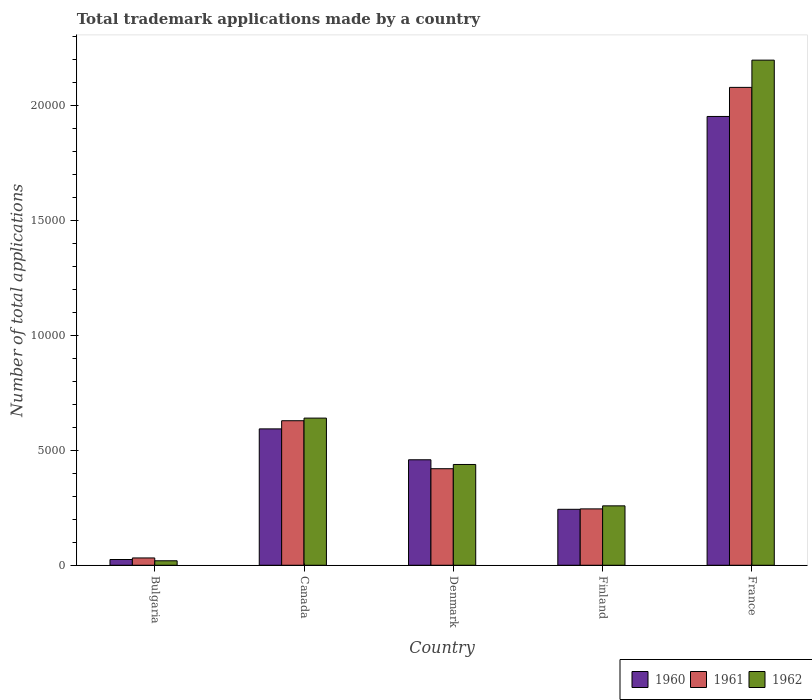How many groups of bars are there?
Make the answer very short. 5. Are the number of bars per tick equal to the number of legend labels?
Ensure brevity in your answer.  Yes. What is the label of the 4th group of bars from the left?
Ensure brevity in your answer.  Finland. In how many cases, is the number of bars for a given country not equal to the number of legend labels?
Provide a short and direct response. 0. What is the number of applications made by in 1962 in Bulgaria?
Offer a terse response. 195. Across all countries, what is the maximum number of applications made by in 1960?
Ensure brevity in your answer.  1.95e+04. Across all countries, what is the minimum number of applications made by in 1960?
Your answer should be very brief. 250. What is the total number of applications made by in 1960 in the graph?
Your answer should be compact. 3.27e+04. What is the difference between the number of applications made by in 1961 in Finland and that in France?
Give a very brief answer. -1.83e+04. What is the difference between the number of applications made by in 1960 in France and the number of applications made by in 1962 in Denmark?
Offer a terse response. 1.51e+04. What is the average number of applications made by in 1961 per country?
Make the answer very short. 6802.6. What is the difference between the number of applications made by of/in 1960 and number of applications made by of/in 1962 in Finland?
Your response must be concise. -150. What is the ratio of the number of applications made by in 1961 in Canada to that in Finland?
Make the answer very short. 2.56. What is the difference between the highest and the second highest number of applications made by in 1961?
Keep it short and to the point. 1.45e+04. What is the difference between the highest and the lowest number of applications made by in 1962?
Keep it short and to the point. 2.18e+04. Is the sum of the number of applications made by in 1960 in Bulgaria and Finland greater than the maximum number of applications made by in 1962 across all countries?
Offer a terse response. No. Are all the bars in the graph horizontal?
Offer a very short reply. No. Are the values on the major ticks of Y-axis written in scientific E-notation?
Keep it short and to the point. No. Does the graph contain any zero values?
Provide a succinct answer. No. Does the graph contain grids?
Provide a succinct answer. No. Where does the legend appear in the graph?
Make the answer very short. Bottom right. How many legend labels are there?
Make the answer very short. 3. What is the title of the graph?
Ensure brevity in your answer.  Total trademark applications made by a country. Does "1982" appear as one of the legend labels in the graph?
Offer a very short reply. No. What is the label or title of the Y-axis?
Your answer should be compact. Number of total applications. What is the Number of total applications of 1960 in Bulgaria?
Provide a succinct answer. 250. What is the Number of total applications of 1961 in Bulgaria?
Make the answer very short. 318. What is the Number of total applications of 1962 in Bulgaria?
Offer a terse response. 195. What is the Number of total applications of 1960 in Canada?
Provide a short and direct response. 5927. What is the Number of total applications of 1961 in Canada?
Your response must be concise. 6281. What is the Number of total applications of 1962 in Canada?
Keep it short and to the point. 6395. What is the Number of total applications in 1960 in Denmark?
Your response must be concise. 4584. What is the Number of total applications in 1961 in Denmark?
Keep it short and to the point. 4196. What is the Number of total applications in 1962 in Denmark?
Make the answer very short. 4380. What is the Number of total applications of 1960 in Finland?
Keep it short and to the point. 2432. What is the Number of total applications of 1961 in Finland?
Provide a succinct answer. 2450. What is the Number of total applications of 1962 in Finland?
Ensure brevity in your answer.  2582. What is the Number of total applications of 1960 in France?
Your answer should be compact. 1.95e+04. What is the Number of total applications in 1961 in France?
Provide a succinct answer. 2.08e+04. What is the Number of total applications of 1962 in France?
Make the answer very short. 2.20e+04. Across all countries, what is the maximum Number of total applications in 1960?
Your answer should be compact. 1.95e+04. Across all countries, what is the maximum Number of total applications of 1961?
Give a very brief answer. 2.08e+04. Across all countries, what is the maximum Number of total applications in 1962?
Keep it short and to the point. 2.20e+04. Across all countries, what is the minimum Number of total applications in 1960?
Make the answer very short. 250. Across all countries, what is the minimum Number of total applications in 1961?
Offer a terse response. 318. Across all countries, what is the minimum Number of total applications in 1962?
Offer a very short reply. 195. What is the total Number of total applications of 1960 in the graph?
Give a very brief answer. 3.27e+04. What is the total Number of total applications of 1961 in the graph?
Give a very brief answer. 3.40e+04. What is the total Number of total applications of 1962 in the graph?
Ensure brevity in your answer.  3.55e+04. What is the difference between the Number of total applications in 1960 in Bulgaria and that in Canada?
Ensure brevity in your answer.  -5677. What is the difference between the Number of total applications in 1961 in Bulgaria and that in Canada?
Make the answer very short. -5963. What is the difference between the Number of total applications in 1962 in Bulgaria and that in Canada?
Offer a very short reply. -6200. What is the difference between the Number of total applications in 1960 in Bulgaria and that in Denmark?
Offer a very short reply. -4334. What is the difference between the Number of total applications of 1961 in Bulgaria and that in Denmark?
Ensure brevity in your answer.  -3878. What is the difference between the Number of total applications of 1962 in Bulgaria and that in Denmark?
Offer a very short reply. -4185. What is the difference between the Number of total applications of 1960 in Bulgaria and that in Finland?
Provide a succinct answer. -2182. What is the difference between the Number of total applications in 1961 in Bulgaria and that in Finland?
Your answer should be compact. -2132. What is the difference between the Number of total applications in 1962 in Bulgaria and that in Finland?
Your response must be concise. -2387. What is the difference between the Number of total applications of 1960 in Bulgaria and that in France?
Provide a short and direct response. -1.93e+04. What is the difference between the Number of total applications of 1961 in Bulgaria and that in France?
Provide a succinct answer. -2.04e+04. What is the difference between the Number of total applications in 1962 in Bulgaria and that in France?
Ensure brevity in your answer.  -2.18e+04. What is the difference between the Number of total applications in 1960 in Canada and that in Denmark?
Offer a terse response. 1343. What is the difference between the Number of total applications in 1961 in Canada and that in Denmark?
Provide a succinct answer. 2085. What is the difference between the Number of total applications of 1962 in Canada and that in Denmark?
Offer a very short reply. 2015. What is the difference between the Number of total applications in 1960 in Canada and that in Finland?
Offer a terse response. 3495. What is the difference between the Number of total applications of 1961 in Canada and that in Finland?
Your response must be concise. 3831. What is the difference between the Number of total applications of 1962 in Canada and that in Finland?
Make the answer very short. 3813. What is the difference between the Number of total applications in 1960 in Canada and that in France?
Ensure brevity in your answer.  -1.36e+04. What is the difference between the Number of total applications of 1961 in Canada and that in France?
Your response must be concise. -1.45e+04. What is the difference between the Number of total applications in 1962 in Canada and that in France?
Provide a short and direct response. -1.56e+04. What is the difference between the Number of total applications of 1960 in Denmark and that in Finland?
Your response must be concise. 2152. What is the difference between the Number of total applications in 1961 in Denmark and that in Finland?
Your answer should be very brief. 1746. What is the difference between the Number of total applications of 1962 in Denmark and that in Finland?
Ensure brevity in your answer.  1798. What is the difference between the Number of total applications of 1960 in Denmark and that in France?
Your answer should be very brief. -1.49e+04. What is the difference between the Number of total applications of 1961 in Denmark and that in France?
Make the answer very short. -1.66e+04. What is the difference between the Number of total applications of 1962 in Denmark and that in France?
Give a very brief answer. -1.76e+04. What is the difference between the Number of total applications in 1960 in Finland and that in France?
Ensure brevity in your answer.  -1.71e+04. What is the difference between the Number of total applications in 1961 in Finland and that in France?
Ensure brevity in your answer.  -1.83e+04. What is the difference between the Number of total applications in 1962 in Finland and that in France?
Offer a very short reply. -1.94e+04. What is the difference between the Number of total applications in 1960 in Bulgaria and the Number of total applications in 1961 in Canada?
Your answer should be very brief. -6031. What is the difference between the Number of total applications in 1960 in Bulgaria and the Number of total applications in 1962 in Canada?
Your response must be concise. -6145. What is the difference between the Number of total applications of 1961 in Bulgaria and the Number of total applications of 1962 in Canada?
Make the answer very short. -6077. What is the difference between the Number of total applications in 1960 in Bulgaria and the Number of total applications in 1961 in Denmark?
Offer a terse response. -3946. What is the difference between the Number of total applications of 1960 in Bulgaria and the Number of total applications of 1962 in Denmark?
Offer a very short reply. -4130. What is the difference between the Number of total applications of 1961 in Bulgaria and the Number of total applications of 1962 in Denmark?
Ensure brevity in your answer.  -4062. What is the difference between the Number of total applications in 1960 in Bulgaria and the Number of total applications in 1961 in Finland?
Keep it short and to the point. -2200. What is the difference between the Number of total applications of 1960 in Bulgaria and the Number of total applications of 1962 in Finland?
Provide a succinct answer. -2332. What is the difference between the Number of total applications of 1961 in Bulgaria and the Number of total applications of 1962 in Finland?
Provide a short and direct response. -2264. What is the difference between the Number of total applications of 1960 in Bulgaria and the Number of total applications of 1961 in France?
Your answer should be compact. -2.05e+04. What is the difference between the Number of total applications in 1960 in Bulgaria and the Number of total applications in 1962 in France?
Keep it short and to the point. -2.17e+04. What is the difference between the Number of total applications of 1961 in Bulgaria and the Number of total applications of 1962 in France?
Ensure brevity in your answer.  -2.16e+04. What is the difference between the Number of total applications of 1960 in Canada and the Number of total applications of 1961 in Denmark?
Keep it short and to the point. 1731. What is the difference between the Number of total applications of 1960 in Canada and the Number of total applications of 1962 in Denmark?
Provide a succinct answer. 1547. What is the difference between the Number of total applications of 1961 in Canada and the Number of total applications of 1962 in Denmark?
Make the answer very short. 1901. What is the difference between the Number of total applications of 1960 in Canada and the Number of total applications of 1961 in Finland?
Give a very brief answer. 3477. What is the difference between the Number of total applications of 1960 in Canada and the Number of total applications of 1962 in Finland?
Provide a short and direct response. 3345. What is the difference between the Number of total applications in 1961 in Canada and the Number of total applications in 1962 in Finland?
Your answer should be very brief. 3699. What is the difference between the Number of total applications in 1960 in Canada and the Number of total applications in 1961 in France?
Make the answer very short. -1.48e+04. What is the difference between the Number of total applications of 1960 in Canada and the Number of total applications of 1962 in France?
Give a very brief answer. -1.60e+04. What is the difference between the Number of total applications in 1961 in Canada and the Number of total applications in 1962 in France?
Your answer should be compact. -1.57e+04. What is the difference between the Number of total applications in 1960 in Denmark and the Number of total applications in 1961 in Finland?
Give a very brief answer. 2134. What is the difference between the Number of total applications in 1960 in Denmark and the Number of total applications in 1962 in Finland?
Keep it short and to the point. 2002. What is the difference between the Number of total applications of 1961 in Denmark and the Number of total applications of 1962 in Finland?
Your answer should be very brief. 1614. What is the difference between the Number of total applications in 1960 in Denmark and the Number of total applications in 1961 in France?
Your answer should be compact. -1.62e+04. What is the difference between the Number of total applications of 1960 in Denmark and the Number of total applications of 1962 in France?
Offer a very short reply. -1.74e+04. What is the difference between the Number of total applications in 1961 in Denmark and the Number of total applications in 1962 in France?
Ensure brevity in your answer.  -1.78e+04. What is the difference between the Number of total applications of 1960 in Finland and the Number of total applications of 1961 in France?
Keep it short and to the point. -1.83e+04. What is the difference between the Number of total applications in 1960 in Finland and the Number of total applications in 1962 in France?
Offer a terse response. -1.95e+04. What is the difference between the Number of total applications of 1961 in Finland and the Number of total applications of 1962 in France?
Keep it short and to the point. -1.95e+04. What is the average Number of total applications in 1960 per country?
Keep it short and to the point. 6539.4. What is the average Number of total applications in 1961 per country?
Ensure brevity in your answer.  6802.6. What is the average Number of total applications in 1962 per country?
Provide a succinct answer. 7100.8. What is the difference between the Number of total applications in 1960 and Number of total applications in 1961 in Bulgaria?
Your answer should be compact. -68. What is the difference between the Number of total applications of 1960 and Number of total applications of 1962 in Bulgaria?
Provide a succinct answer. 55. What is the difference between the Number of total applications in 1961 and Number of total applications in 1962 in Bulgaria?
Provide a succinct answer. 123. What is the difference between the Number of total applications of 1960 and Number of total applications of 1961 in Canada?
Your response must be concise. -354. What is the difference between the Number of total applications in 1960 and Number of total applications in 1962 in Canada?
Offer a terse response. -468. What is the difference between the Number of total applications in 1961 and Number of total applications in 1962 in Canada?
Give a very brief answer. -114. What is the difference between the Number of total applications in 1960 and Number of total applications in 1961 in Denmark?
Keep it short and to the point. 388. What is the difference between the Number of total applications in 1960 and Number of total applications in 1962 in Denmark?
Offer a terse response. 204. What is the difference between the Number of total applications in 1961 and Number of total applications in 1962 in Denmark?
Ensure brevity in your answer.  -184. What is the difference between the Number of total applications of 1960 and Number of total applications of 1961 in Finland?
Your response must be concise. -18. What is the difference between the Number of total applications of 1960 and Number of total applications of 1962 in Finland?
Your answer should be compact. -150. What is the difference between the Number of total applications of 1961 and Number of total applications of 1962 in Finland?
Your response must be concise. -132. What is the difference between the Number of total applications of 1960 and Number of total applications of 1961 in France?
Your response must be concise. -1264. What is the difference between the Number of total applications in 1960 and Number of total applications in 1962 in France?
Offer a terse response. -2448. What is the difference between the Number of total applications in 1961 and Number of total applications in 1962 in France?
Your response must be concise. -1184. What is the ratio of the Number of total applications of 1960 in Bulgaria to that in Canada?
Offer a terse response. 0.04. What is the ratio of the Number of total applications in 1961 in Bulgaria to that in Canada?
Ensure brevity in your answer.  0.05. What is the ratio of the Number of total applications in 1962 in Bulgaria to that in Canada?
Keep it short and to the point. 0.03. What is the ratio of the Number of total applications in 1960 in Bulgaria to that in Denmark?
Your answer should be very brief. 0.05. What is the ratio of the Number of total applications in 1961 in Bulgaria to that in Denmark?
Offer a terse response. 0.08. What is the ratio of the Number of total applications of 1962 in Bulgaria to that in Denmark?
Offer a terse response. 0.04. What is the ratio of the Number of total applications of 1960 in Bulgaria to that in Finland?
Ensure brevity in your answer.  0.1. What is the ratio of the Number of total applications of 1961 in Bulgaria to that in Finland?
Keep it short and to the point. 0.13. What is the ratio of the Number of total applications in 1962 in Bulgaria to that in Finland?
Offer a terse response. 0.08. What is the ratio of the Number of total applications of 1960 in Bulgaria to that in France?
Your answer should be very brief. 0.01. What is the ratio of the Number of total applications of 1961 in Bulgaria to that in France?
Your answer should be compact. 0.02. What is the ratio of the Number of total applications in 1962 in Bulgaria to that in France?
Provide a succinct answer. 0.01. What is the ratio of the Number of total applications of 1960 in Canada to that in Denmark?
Ensure brevity in your answer.  1.29. What is the ratio of the Number of total applications in 1961 in Canada to that in Denmark?
Your response must be concise. 1.5. What is the ratio of the Number of total applications of 1962 in Canada to that in Denmark?
Provide a succinct answer. 1.46. What is the ratio of the Number of total applications in 1960 in Canada to that in Finland?
Provide a short and direct response. 2.44. What is the ratio of the Number of total applications of 1961 in Canada to that in Finland?
Ensure brevity in your answer.  2.56. What is the ratio of the Number of total applications of 1962 in Canada to that in Finland?
Provide a succinct answer. 2.48. What is the ratio of the Number of total applications in 1960 in Canada to that in France?
Ensure brevity in your answer.  0.3. What is the ratio of the Number of total applications of 1961 in Canada to that in France?
Your response must be concise. 0.3. What is the ratio of the Number of total applications in 1962 in Canada to that in France?
Make the answer very short. 0.29. What is the ratio of the Number of total applications of 1960 in Denmark to that in Finland?
Provide a short and direct response. 1.88. What is the ratio of the Number of total applications in 1961 in Denmark to that in Finland?
Ensure brevity in your answer.  1.71. What is the ratio of the Number of total applications in 1962 in Denmark to that in Finland?
Offer a very short reply. 1.7. What is the ratio of the Number of total applications of 1960 in Denmark to that in France?
Your response must be concise. 0.23. What is the ratio of the Number of total applications in 1961 in Denmark to that in France?
Offer a terse response. 0.2. What is the ratio of the Number of total applications of 1962 in Denmark to that in France?
Provide a short and direct response. 0.2. What is the ratio of the Number of total applications in 1960 in Finland to that in France?
Provide a succinct answer. 0.12. What is the ratio of the Number of total applications in 1961 in Finland to that in France?
Your answer should be compact. 0.12. What is the ratio of the Number of total applications in 1962 in Finland to that in France?
Make the answer very short. 0.12. What is the difference between the highest and the second highest Number of total applications of 1960?
Your answer should be compact. 1.36e+04. What is the difference between the highest and the second highest Number of total applications of 1961?
Offer a terse response. 1.45e+04. What is the difference between the highest and the second highest Number of total applications in 1962?
Your answer should be very brief. 1.56e+04. What is the difference between the highest and the lowest Number of total applications in 1960?
Your answer should be compact. 1.93e+04. What is the difference between the highest and the lowest Number of total applications of 1961?
Provide a succinct answer. 2.04e+04. What is the difference between the highest and the lowest Number of total applications in 1962?
Your answer should be very brief. 2.18e+04. 